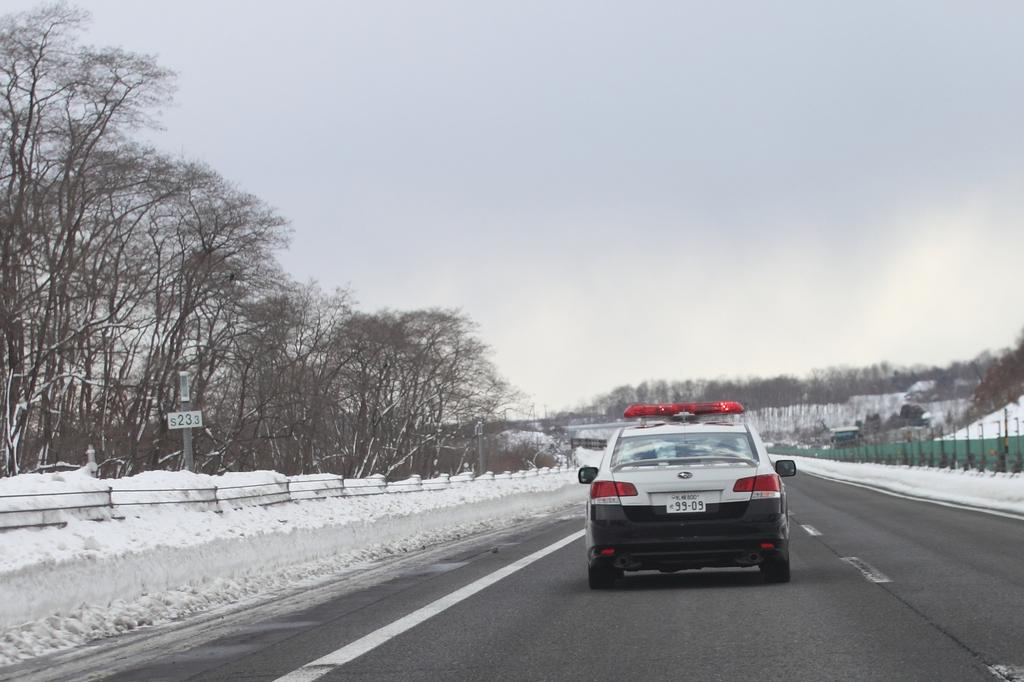What is on the road in the image? There is a vehicle on the road in the image. What can be seen beside the vehicle? There are trees and boards beside the vehicle. What is the ground condition beside the vehicle? There is snow beside the vehicle. What is visible far from the vehicle? There are trees far from the vehicle. How would you describe the sky in the image? The sky is cloudy in the image. What type of meat is being protested against in the image? There is no protest or meat present in the image; it features a vehicle on the road with trees, boards, snow, and a cloudy sky. 